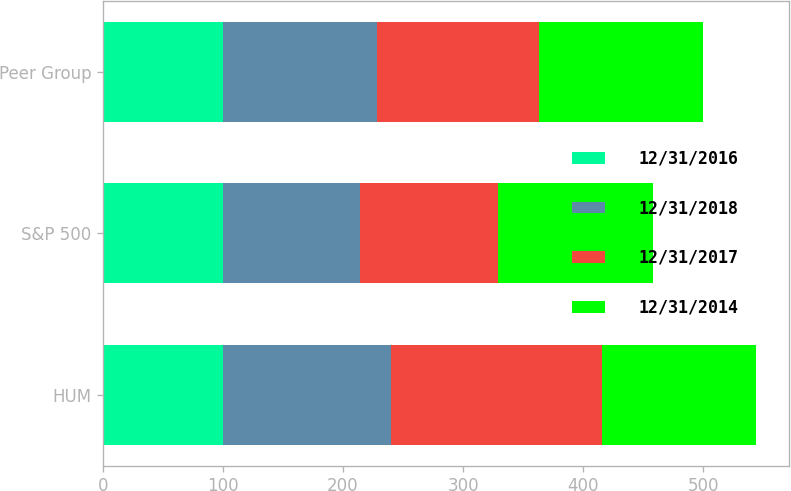Convert chart to OTSL. <chart><loc_0><loc_0><loc_500><loc_500><stacked_bar_chart><ecel><fcel>HUM<fcel>S&P 500<fcel>Peer Group<nl><fcel>12/31/2016<fcel>100<fcel>100<fcel>100<nl><fcel>12/31/2018<fcel>140<fcel>114<fcel>128<nl><fcel>12/31/2017<fcel>176<fcel>115<fcel>135<nl><fcel>12/31/2014<fcel>128<fcel>129<fcel>137<nl></chart> 